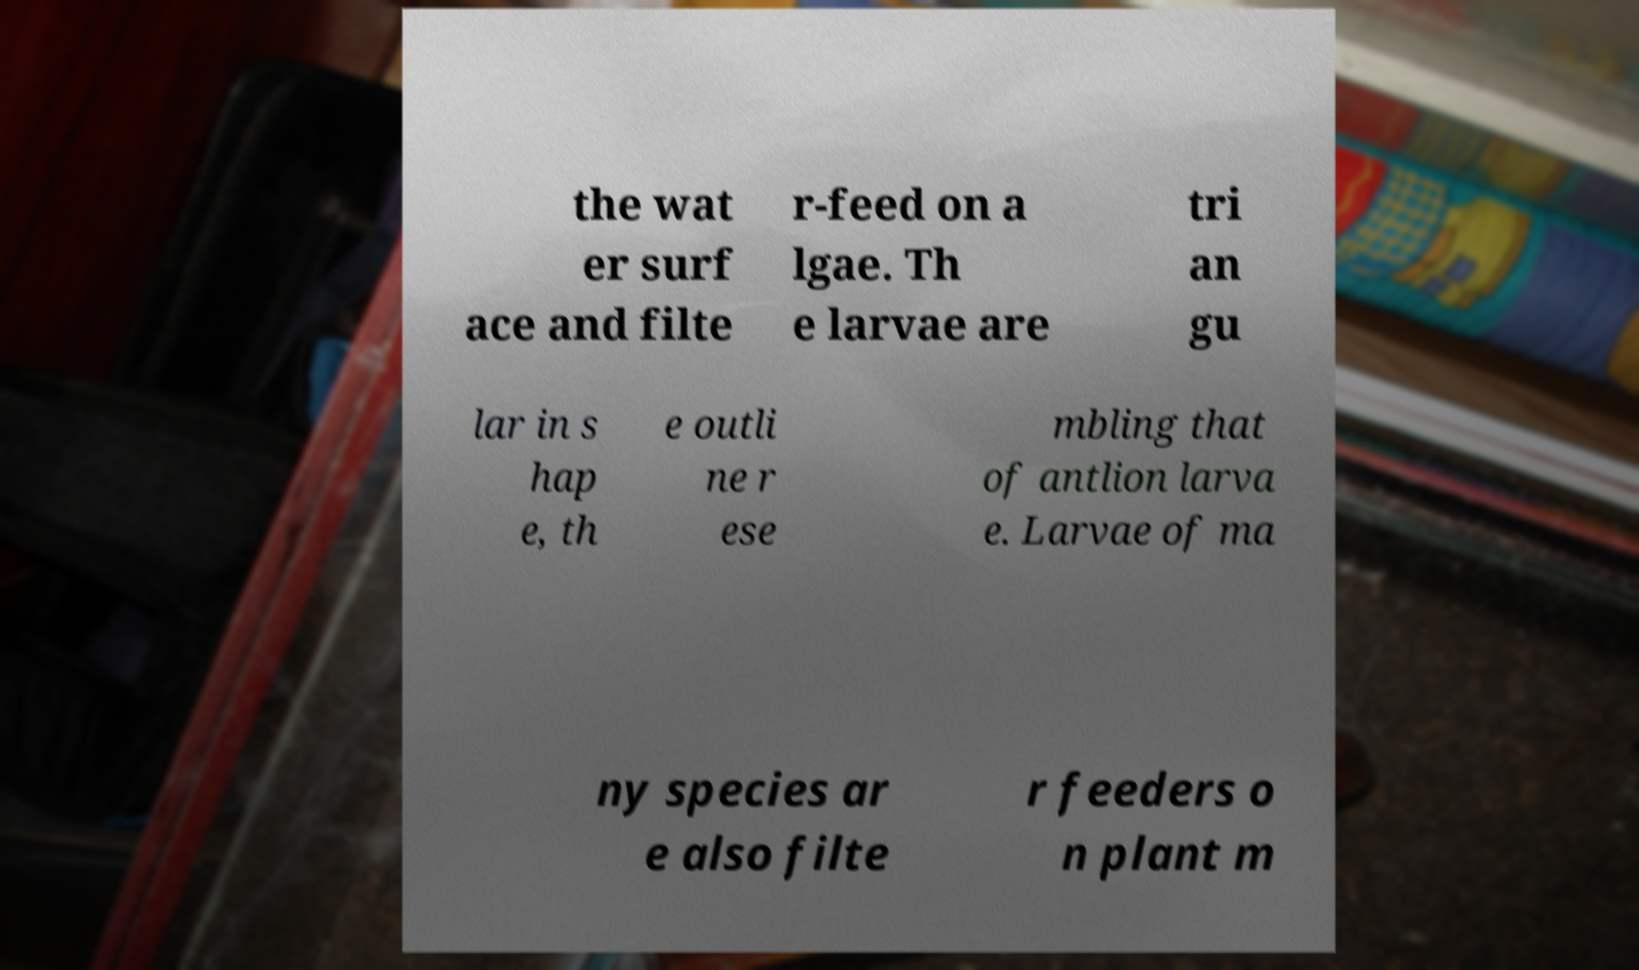Can you read and provide the text displayed in the image?This photo seems to have some interesting text. Can you extract and type it out for me? the wat er surf ace and filte r-feed on a lgae. Th e larvae are tri an gu lar in s hap e, th e outli ne r ese mbling that of antlion larva e. Larvae of ma ny species ar e also filte r feeders o n plant m 